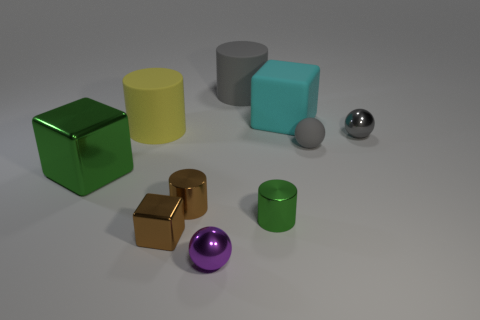How many objects are either tiny gray metallic blocks or balls that are to the left of the tiny gray matte thing?
Make the answer very short. 1. Is the material of the small brown block the same as the green cube?
Your response must be concise. Yes. Is the number of cyan things on the left side of the big yellow matte object the same as the number of brown objects in front of the tiny metal block?
Give a very brief answer. Yes. How many purple balls are on the left side of the large cyan object?
Offer a terse response. 1. What number of things are either gray spheres or large green metallic things?
Your answer should be very brief. 3. How many yellow objects are the same size as the rubber cube?
Offer a very short reply. 1. There is a green object left of the big yellow cylinder left of the brown cylinder; what is its shape?
Your response must be concise. Cube. Is the number of small brown things less than the number of tiny yellow metallic spheres?
Ensure brevity in your answer.  No. What is the color of the metallic ball behind the green shiny cube?
Your answer should be compact. Gray. What is the cylinder that is both right of the tiny purple ball and to the left of the small green metal cylinder made of?
Make the answer very short. Rubber. 